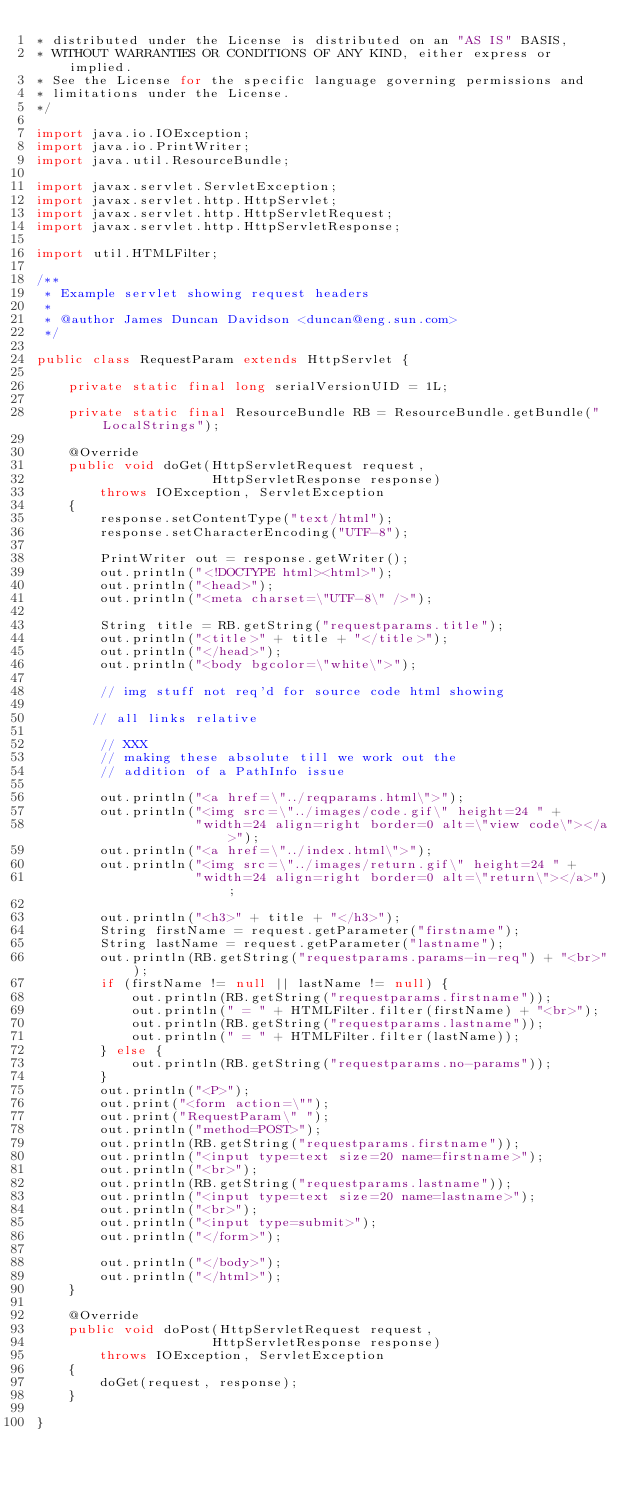<code> <loc_0><loc_0><loc_500><loc_500><_Java_>* distributed under the License is distributed on an "AS IS" BASIS,
* WITHOUT WARRANTIES OR CONDITIONS OF ANY KIND, either express or implied.
* See the License for the specific language governing permissions and
* limitations under the License.
*/

import java.io.IOException;
import java.io.PrintWriter;
import java.util.ResourceBundle;

import javax.servlet.ServletException;
import javax.servlet.http.HttpServlet;
import javax.servlet.http.HttpServletRequest;
import javax.servlet.http.HttpServletResponse;

import util.HTMLFilter;

/**
 * Example servlet showing request headers
 *
 * @author James Duncan Davidson <duncan@eng.sun.com>
 */

public class RequestParam extends HttpServlet {

    private static final long serialVersionUID = 1L;

    private static final ResourceBundle RB = ResourceBundle.getBundle("LocalStrings");

    @Override
    public void doGet(HttpServletRequest request,
                      HttpServletResponse response)
        throws IOException, ServletException
    {
        response.setContentType("text/html");
        response.setCharacterEncoding("UTF-8");

        PrintWriter out = response.getWriter();
        out.println("<!DOCTYPE html><html>");
        out.println("<head>");
        out.println("<meta charset=\"UTF-8\" />");

        String title = RB.getString("requestparams.title");
        out.println("<title>" + title + "</title>");
        out.println("</head>");
        out.println("<body bgcolor=\"white\">");

        // img stuff not req'd for source code html showing

       // all links relative

        // XXX
        // making these absolute till we work out the
        // addition of a PathInfo issue

        out.println("<a href=\"../reqparams.html\">");
        out.println("<img src=\"../images/code.gif\" height=24 " +
                    "width=24 align=right border=0 alt=\"view code\"></a>");
        out.println("<a href=\"../index.html\">");
        out.println("<img src=\"../images/return.gif\" height=24 " +
                    "width=24 align=right border=0 alt=\"return\"></a>");

        out.println("<h3>" + title + "</h3>");
        String firstName = request.getParameter("firstname");
        String lastName = request.getParameter("lastname");
        out.println(RB.getString("requestparams.params-in-req") + "<br>");
        if (firstName != null || lastName != null) {
            out.println(RB.getString("requestparams.firstname"));
            out.println(" = " + HTMLFilter.filter(firstName) + "<br>");
            out.println(RB.getString("requestparams.lastname"));
            out.println(" = " + HTMLFilter.filter(lastName));
        } else {
            out.println(RB.getString("requestparams.no-params"));
        }
        out.println("<P>");
        out.print("<form action=\"");
        out.print("RequestParam\" ");
        out.println("method=POST>");
        out.println(RB.getString("requestparams.firstname"));
        out.println("<input type=text size=20 name=firstname>");
        out.println("<br>");
        out.println(RB.getString("requestparams.lastname"));
        out.println("<input type=text size=20 name=lastname>");
        out.println("<br>");
        out.println("<input type=submit>");
        out.println("</form>");

        out.println("</body>");
        out.println("</html>");
    }

    @Override
    public void doPost(HttpServletRequest request,
                      HttpServletResponse response)
        throws IOException, ServletException
    {
        doGet(request, response);
    }

}
</code> 